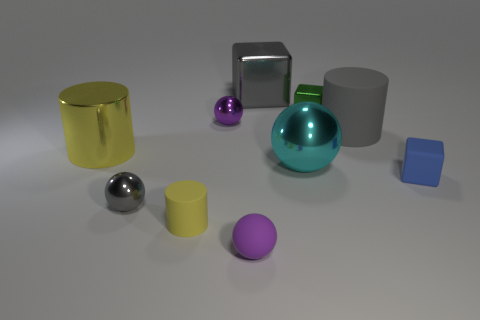If the cylinder wasn't large and yellow, how would that change the composition? If the cylinder were not large and yellow, it would significantly alter the visual composition. A smaller size would reduce its dominance in the scene, and a different color could shift the focal balance, potentially making another object stand out or creating a different aesthetic harmony among the shapes. 